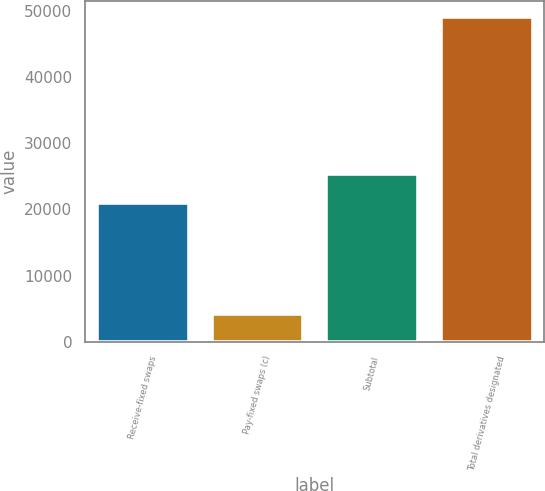<chart> <loc_0><loc_0><loc_500><loc_500><bar_chart><fcel>Receive-fixed swaps<fcel>Pay-fixed swaps (c)<fcel>Subtotal<fcel>Total derivatives designated<nl><fcel>20930<fcel>4233<fcel>25412.8<fcel>49061<nl></chart> 